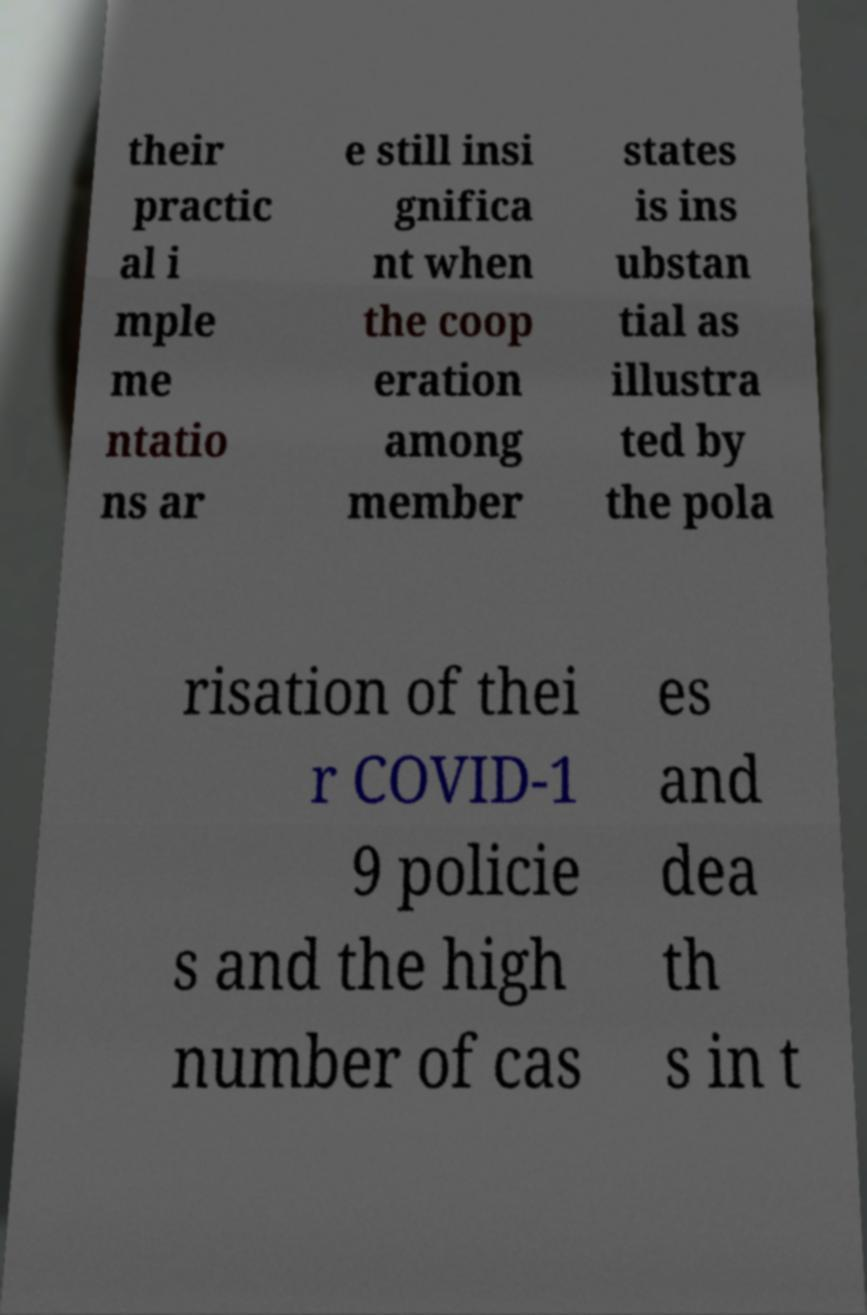Please read and relay the text visible in this image. What does it say? their practic al i mple me ntatio ns ar e still insi gnifica nt when the coop eration among member states is ins ubstan tial as illustra ted by the pola risation of thei r COVID-1 9 policie s and the high number of cas es and dea th s in t 